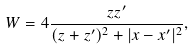<formula> <loc_0><loc_0><loc_500><loc_500>W = 4 \frac { z z ^ { \prime } } { ( z + z ^ { \prime } ) ^ { 2 } + | x - x ^ { \prime } | ^ { 2 } } ,</formula> 